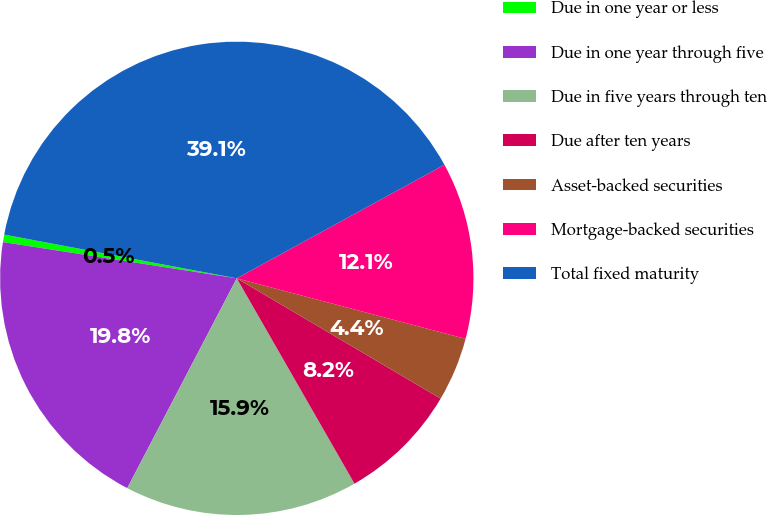Convert chart. <chart><loc_0><loc_0><loc_500><loc_500><pie_chart><fcel>Due in one year or less<fcel>Due in one year through five<fcel>Due in five years through ten<fcel>Due after ten years<fcel>Asset-backed securities<fcel>Mortgage-backed securities<fcel>Total fixed maturity<nl><fcel>0.51%<fcel>19.79%<fcel>15.94%<fcel>8.23%<fcel>4.37%<fcel>12.08%<fcel>39.07%<nl></chart> 